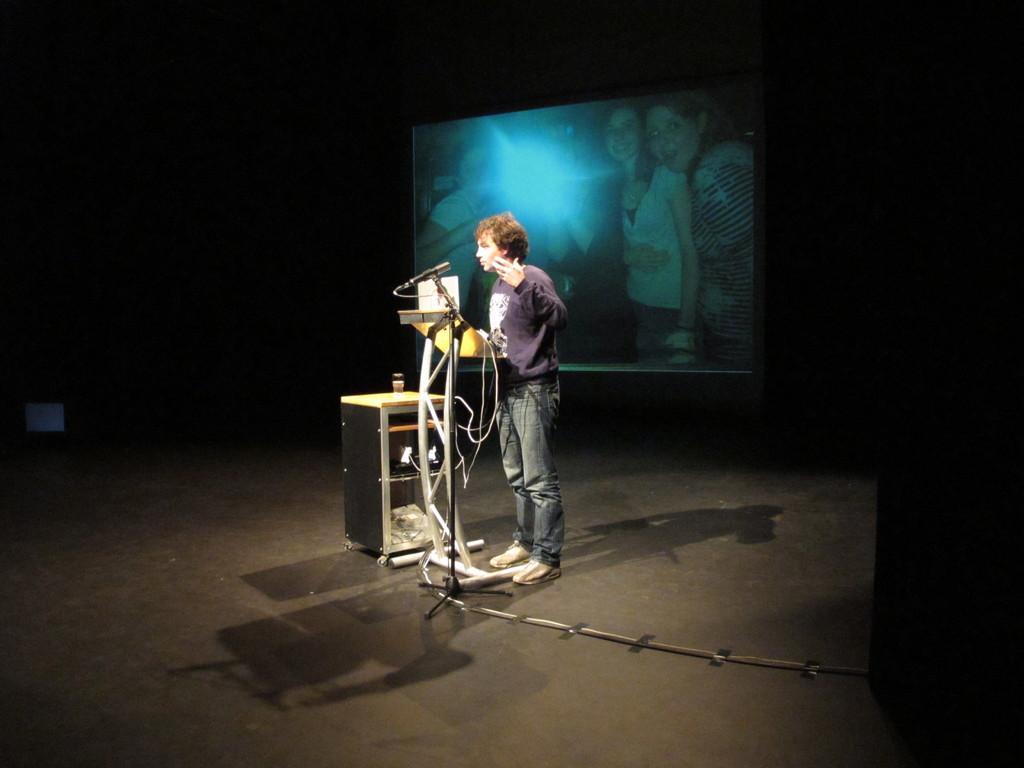How would you summarize this image in a sentence or two? In this image there is a person standing in front of the table and mic, beside him there is another table with some stuff in it, behind the person there is a screen. On the screen there are a few people standing with a smile on their face. The background is dark. 